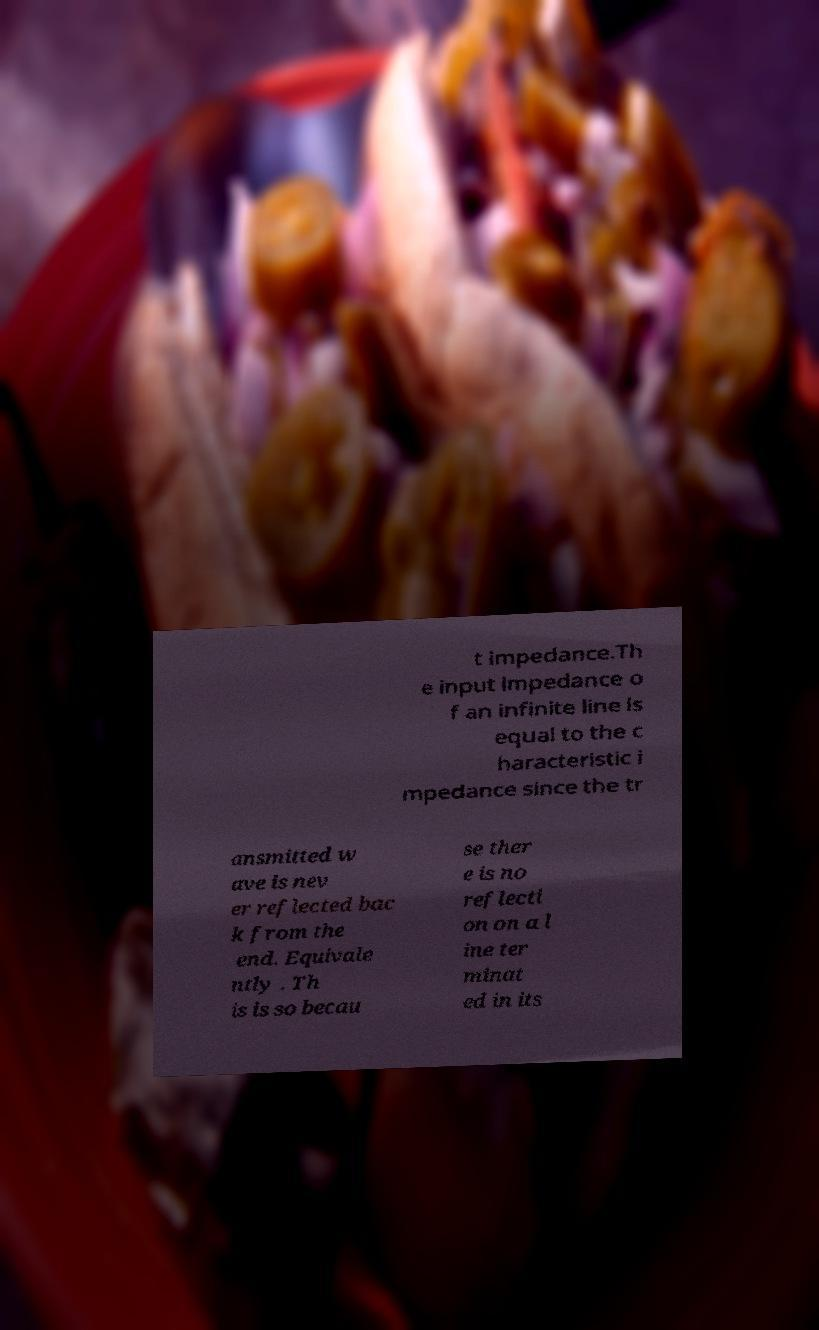I need the written content from this picture converted into text. Can you do that? t impedance.Th e input impedance o f an infinite line is equal to the c haracteristic i mpedance since the tr ansmitted w ave is nev er reflected bac k from the end. Equivale ntly . Th is is so becau se ther e is no reflecti on on a l ine ter minat ed in its 